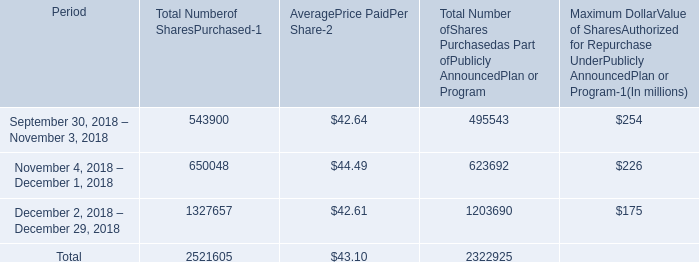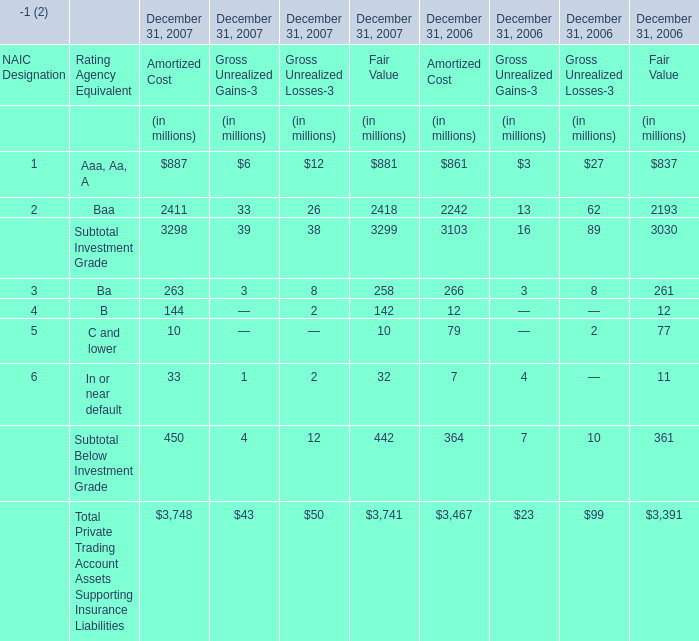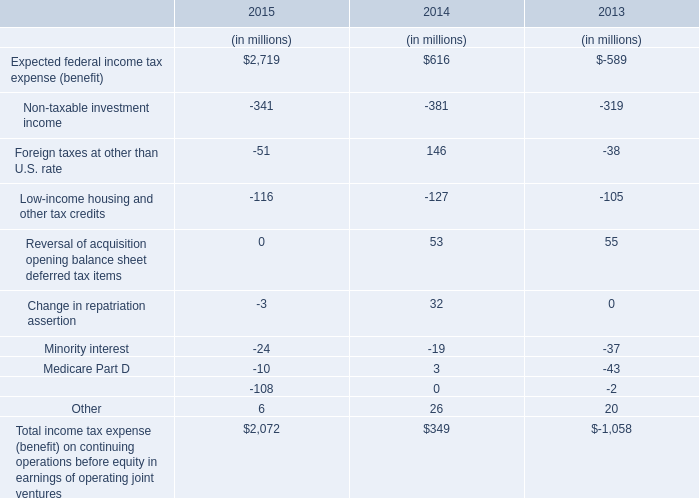In the year with largest amount of B, what's the increasing rate of Ba forAmortized Cost 
Computations: ((263 - 266) / 263)
Answer: -0.01141. 